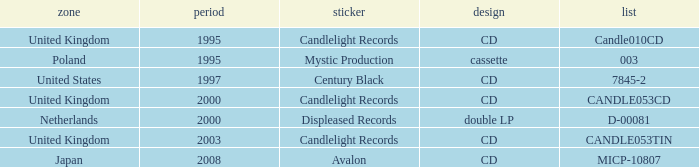What was the Candlelight Records Catalog of Candle053tin format? CD. 